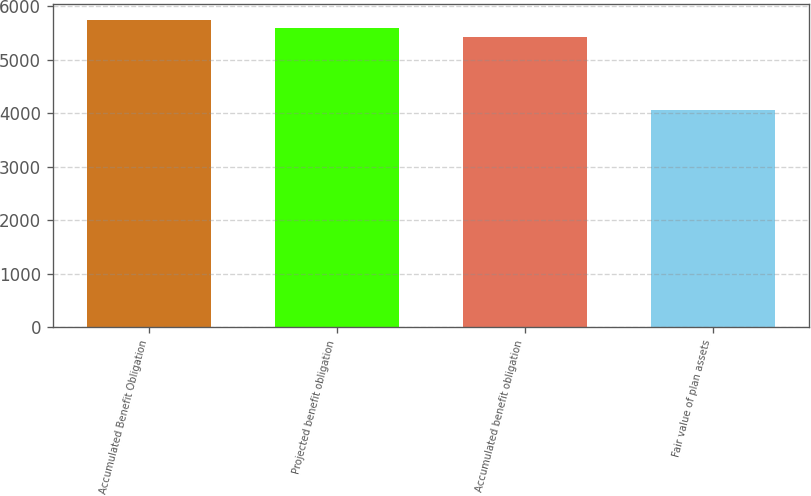<chart> <loc_0><loc_0><loc_500><loc_500><bar_chart><fcel>Accumulated Benefit Obligation<fcel>Projected benefit obligation<fcel>Accumulated benefit obligation<fcel>Fair value of plan assets<nl><fcel>5753.4<fcel>5588.2<fcel>5423<fcel>4072<nl></chart> 